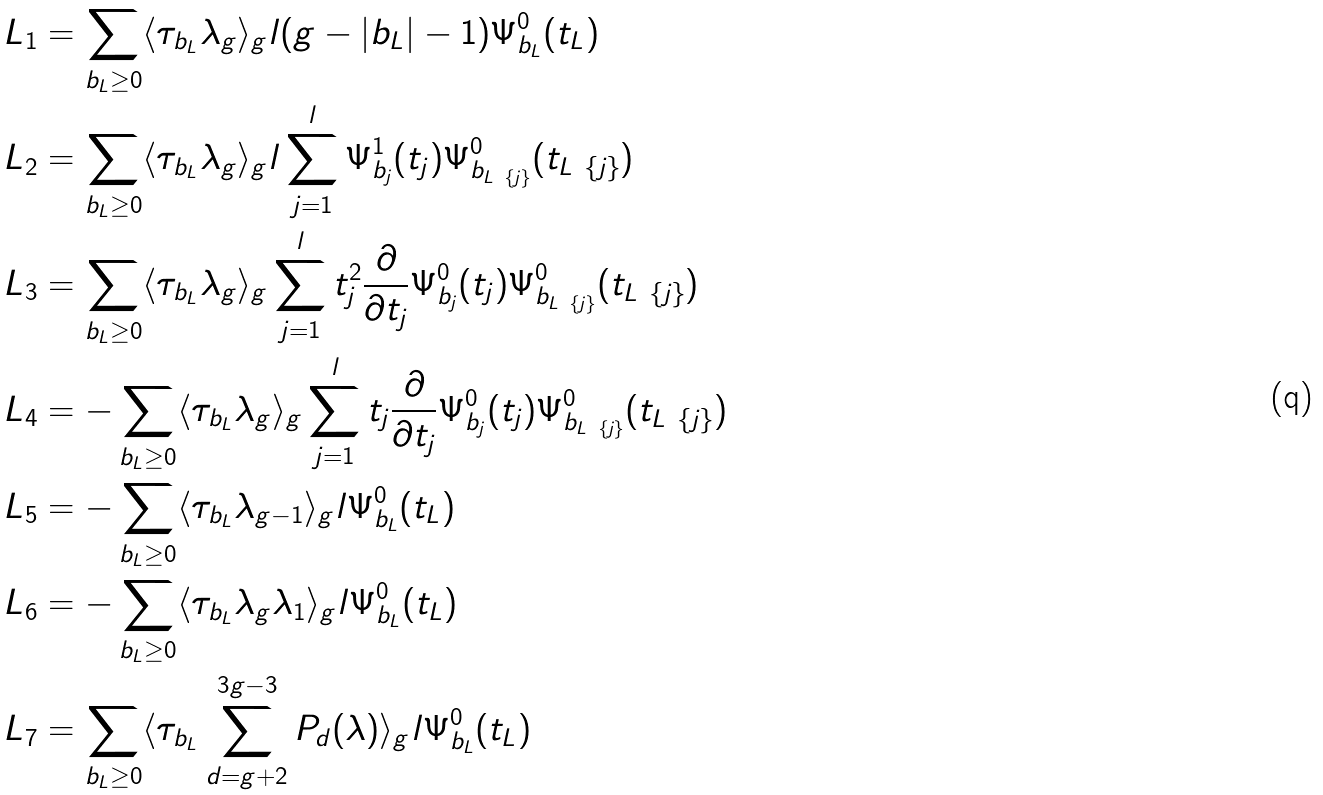Convert formula to latex. <formula><loc_0><loc_0><loc_500><loc_500>& L _ { 1 } = \sum _ { b _ { L } \geq 0 } \langle \tau _ { b _ { L } } \lambda _ { g } \rangle _ { g } l ( g - | b _ { L } | - 1 ) \Psi _ { b _ { L } } ^ { 0 } ( t _ { L } ) \\ & L _ { 2 } = \sum _ { b _ { L } \geq 0 } \langle \tau _ { b _ { L } } \lambda _ { g } \rangle _ { g } l \sum _ { j = 1 } ^ { l } \Psi _ { b _ { j } } ^ { 1 } ( t _ { j } ) \Psi _ { b _ { L \ \{ j \} } } ^ { 0 } ( t _ { L \ \{ j \} } ) \\ & L _ { 3 } = \sum _ { b _ { L } \geq 0 } \langle \tau _ { b _ { L } } \lambda _ { g } \rangle _ { g } \sum _ { j = 1 } ^ { l } t _ { j } ^ { 2 } \frac { \partial } { \partial t _ { j } } \Psi _ { b _ { j } } ^ { 0 } ( t _ { j } ) \Psi _ { b _ { L \ \{ j \} } } ^ { 0 } ( t _ { L \ \{ j \} } ) \\ & L _ { 4 } = - \sum _ { b _ { L } \geq 0 } \langle \tau _ { b _ { L } } \lambda _ { g } \rangle _ { g } \sum _ { j = 1 } ^ { l } t _ { j } \frac { \partial } { \partial t _ { j } } \Psi _ { b _ { j } } ^ { 0 } ( t _ { j } ) \Psi _ { b _ { L \ \{ j \} } } ^ { 0 } ( t _ { L \ \{ j \} } ) \\ & L _ { 5 } = - \sum _ { b _ { L } \geq 0 } \langle \tau _ { b _ { L } } \lambda _ { g - 1 } \rangle _ { g } l \Psi _ { b _ { L } } ^ { 0 } ( t _ { L } ) \\ & L _ { 6 } = - \sum _ { b _ { L } \geq 0 } \langle \tau _ { b _ { L } } \lambda _ { g } \lambda _ { 1 } \rangle _ { g } l \Psi _ { b _ { L } } ^ { 0 } ( t _ { L } ) \\ & L _ { 7 } = \sum _ { b _ { L } \geq 0 } \langle \tau _ { b _ { L } } \sum _ { d = g + 2 } ^ { 3 g - 3 } P _ { d } ( \lambda ) \rangle _ { g } l \Psi _ { b _ { L } } ^ { 0 } ( t _ { L } )</formula> 